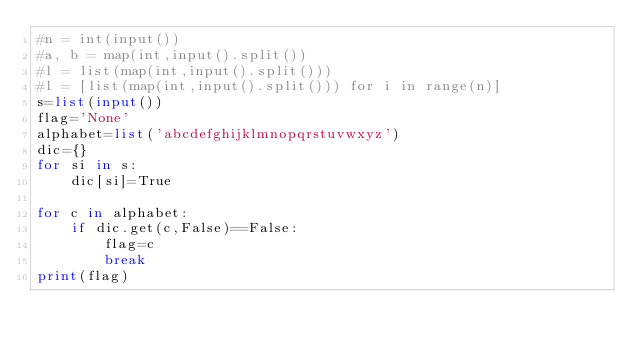<code> <loc_0><loc_0><loc_500><loc_500><_Python_>#n = int(input())
#a, b = map(int,input().split())
#l = list(map(int,input().split()))
#l = [list(map(int,input().split())) for i in range(n)]
s=list(input())
flag='None'
alphabet=list('abcdefghijklmnopqrstuvwxyz')
dic={}
for si in s:
    dic[si]=True

for c in alphabet:
    if dic.get(c,False)==False:
        flag=c
        break
print(flag)</code> 